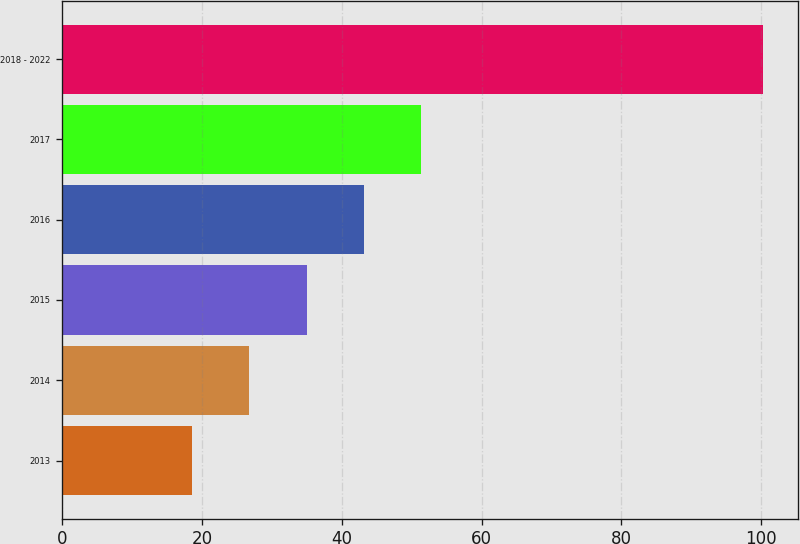<chart> <loc_0><loc_0><loc_500><loc_500><bar_chart><fcel>2013<fcel>2014<fcel>2015<fcel>2016<fcel>2017<fcel>2018 - 2022<nl><fcel>18.6<fcel>26.77<fcel>34.94<fcel>43.11<fcel>51.28<fcel>100.3<nl></chart> 